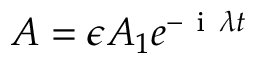Convert formula to latex. <formula><loc_0><loc_0><loc_500><loc_500>A = \epsilon A _ { 1 } e ^ { - i \lambda t }</formula> 